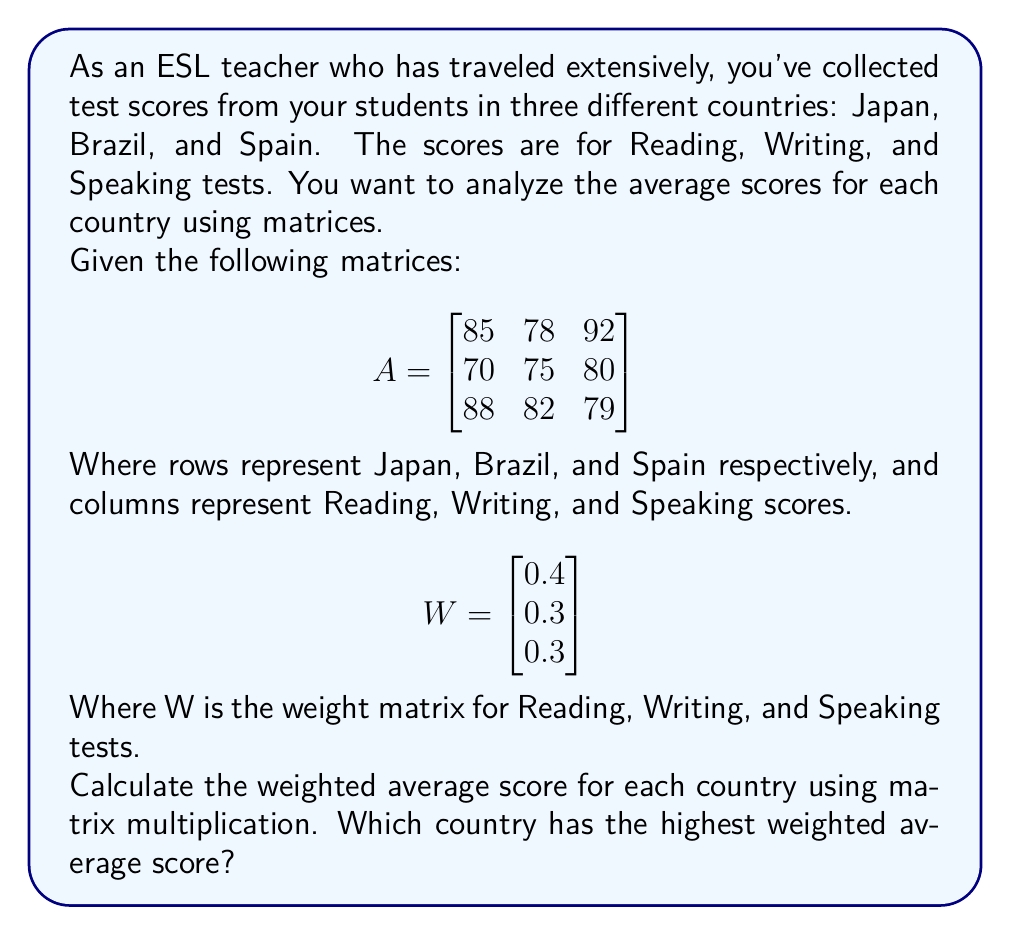Help me with this question. To solve this problem, we need to follow these steps:

1) First, we need to multiply matrix A by matrix W. This will give us a new matrix with the weighted average scores for each country.

2) The formula for this multiplication is:

   $$AW = \begin{bmatrix}
   85 & 78 & 92 \\
   70 & 75 & 80 \\
   88 & 82 & 79
   \end{bmatrix} \times \begin{bmatrix}
   0.4 \\
   0.3 \\
   0.3
   \end{bmatrix}$$

3) Let's calculate each row:

   For Japan:
   $$(85 \times 0.4) + (78 \times 0.3) + (92 \times 0.3) = 34 + 23.4 + 27.6 = 85$$

   For Brazil:
   $$(70 \times 0.4) + (75 \times 0.3) + (80 \times 0.3) = 28 + 22.5 + 24 = 74.5$$

   For Spain:
   $$(88 \times 0.4) + (82 \times 0.3) + (79 \times 0.3) = 35.2 + 24.6 + 23.7 = 83.5$$

4) The resulting matrix is:

   $$AW = \begin{bmatrix}
   85 \\
   74.5 \\
   83.5
   \end{bmatrix}$$

5) Comparing these scores, we can see that Japan has the highest weighted average score of 85.
Answer: Japan, with a weighted average score of 85. 